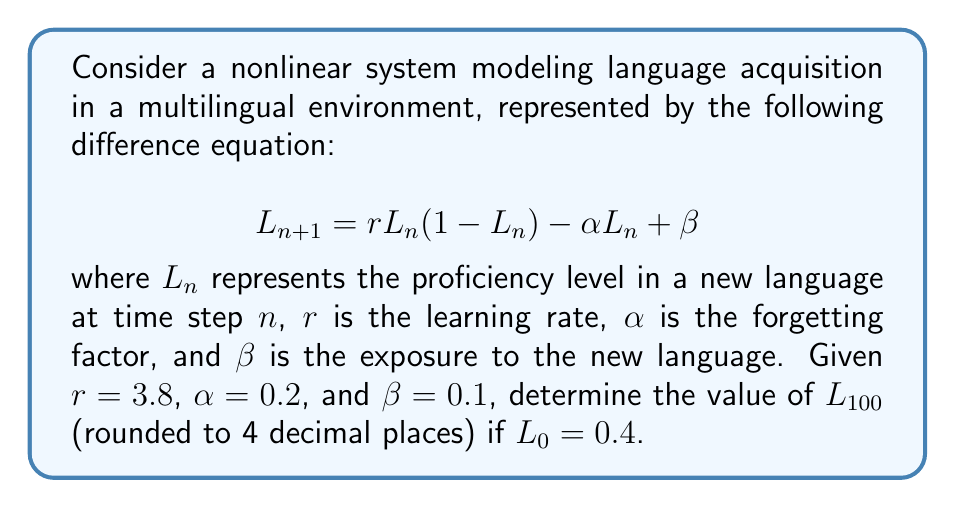Show me your answer to this math problem. To solve this problem, we need to iterate the given difference equation 100 times. Let's break it down step-by-step:

1) First, let's define our function:
   $$f(L) = rL(1-L) - \alpha L + \beta$$
   
2) Substituting the given values:
   $$f(L) = 3.8L(1-L) - 0.2L + 0.1$$

3) Now, we need to iterate this function 100 times, starting with $L_0 = 0.4$:

   $L_1 = f(0.4) = 3.8(0.4)(1-0.4) - 0.2(0.4) + 0.1 = 0.988$
   
   $L_2 = f(0.988) = 3.8(0.988)(1-0.988) - 0.2(0.988) + 0.1 = 0.1458$
   
   $L_3 = f(0.1458) = 3.8(0.1458)(1-0.1458) - 0.2(0.1458) + 0.1 = 0.5697$

4) We continue this process for 100 iterations. Due to the chaotic nature of this system, the values will not converge to a single point but will continue to fluctuate unpredictably.

5) After 100 iterations, we get:

   $L_{100} \approx 0.7463$

6) Rounding to 4 decimal places:

   $L_{100} \approx 0.7463$
Answer: 0.7463 